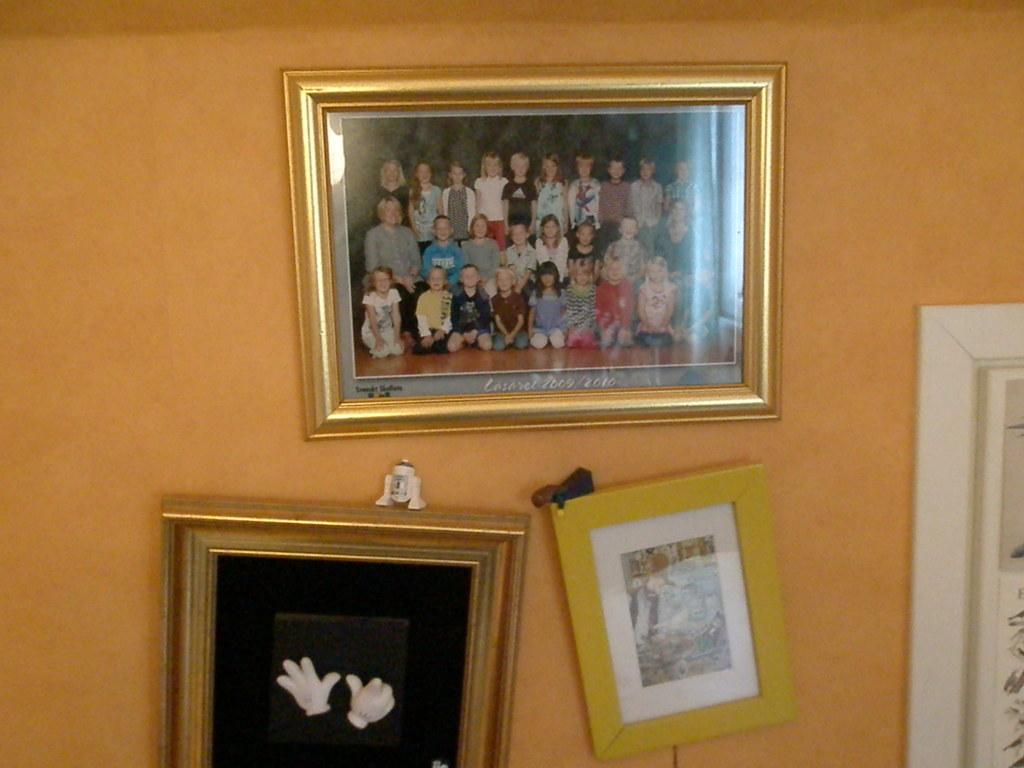<image>
Relay a brief, clear account of the picture shown. A group photo from 2009-2010 hangs on a wall with other crooked pictures. 